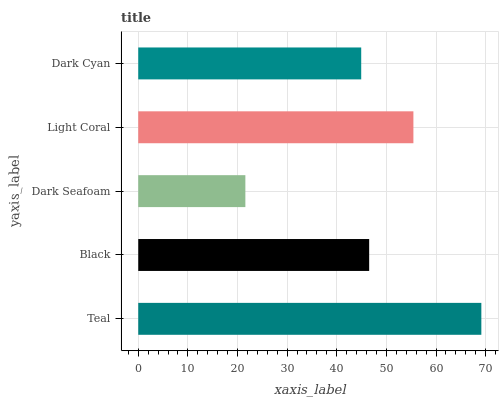Is Dark Seafoam the minimum?
Answer yes or no. Yes. Is Teal the maximum?
Answer yes or no. Yes. Is Black the minimum?
Answer yes or no. No. Is Black the maximum?
Answer yes or no. No. Is Teal greater than Black?
Answer yes or no. Yes. Is Black less than Teal?
Answer yes or no. Yes. Is Black greater than Teal?
Answer yes or no. No. Is Teal less than Black?
Answer yes or no. No. Is Black the high median?
Answer yes or no. Yes. Is Black the low median?
Answer yes or no. Yes. Is Dark Cyan the high median?
Answer yes or no. No. Is Dark Cyan the low median?
Answer yes or no. No. 